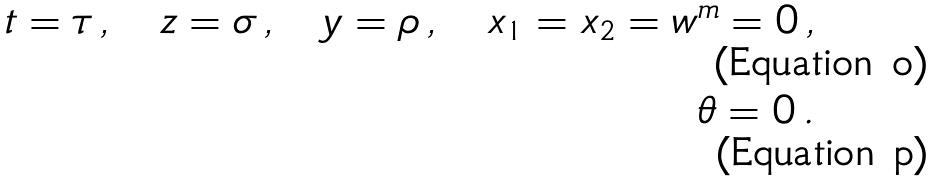<formula> <loc_0><loc_0><loc_500><loc_500>t = \tau \, , \quad z = \sigma \, , \quad y = \rho \, , \quad x _ { 1 } = x _ { 2 } = w ^ { m } = 0 \, , \\ \theta = 0 \, .</formula> 